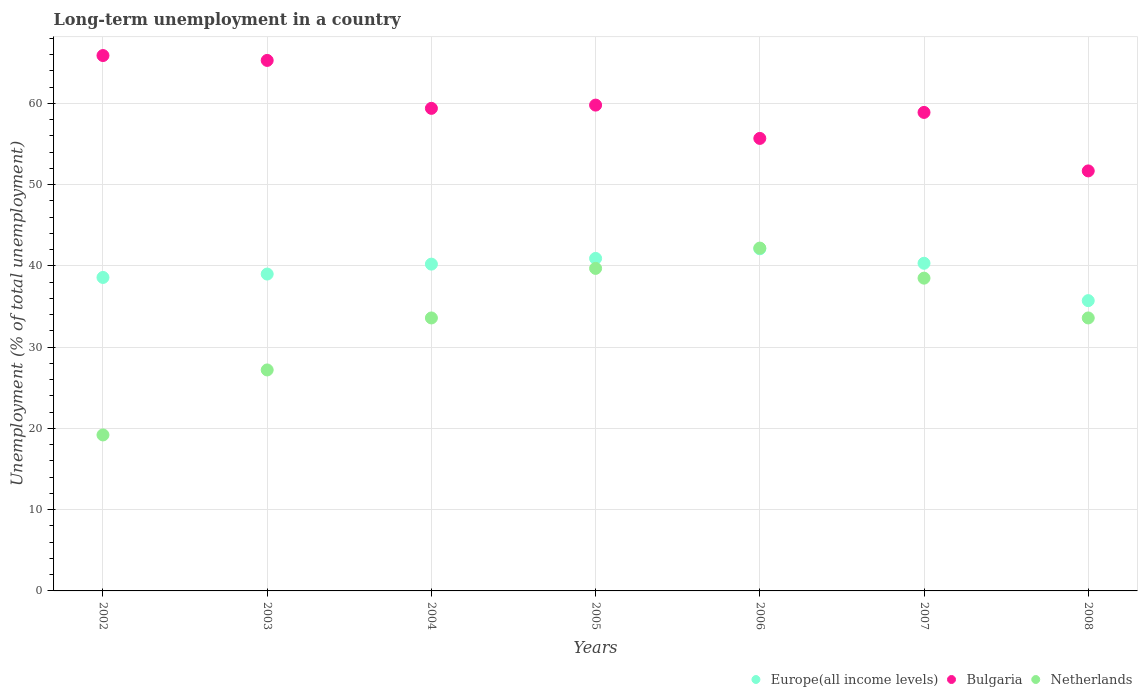Is the number of dotlines equal to the number of legend labels?
Offer a terse response. Yes. What is the percentage of long-term unemployed population in Europe(all income levels) in 2002?
Your response must be concise. 38.59. Across all years, what is the maximum percentage of long-term unemployed population in Europe(all income levels)?
Offer a very short reply. 42.11. Across all years, what is the minimum percentage of long-term unemployed population in Netherlands?
Give a very brief answer. 19.2. In which year was the percentage of long-term unemployed population in Europe(all income levels) maximum?
Make the answer very short. 2006. In which year was the percentage of long-term unemployed population in Netherlands minimum?
Provide a short and direct response. 2002. What is the total percentage of long-term unemployed population in Bulgaria in the graph?
Offer a very short reply. 416.7. What is the difference between the percentage of long-term unemployed population in Europe(all income levels) in 2004 and that in 2006?
Keep it short and to the point. -1.89. What is the difference between the percentage of long-term unemployed population in Bulgaria in 2004 and the percentage of long-term unemployed population in Netherlands in 2005?
Make the answer very short. 19.7. What is the average percentage of long-term unemployed population in Europe(all income levels) per year?
Offer a very short reply. 39.56. In the year 2003, what is the difference between the percentage of long-term unemployed population in Bulgaria and percentage of long-term unemployed population in Netherlands?
Offer a terse response. 38.1. In how many years, is the percentage of long-term unemployed population in Europe(all income levels) greater than 48 %?
Your response must be concise. 0. What is the ratio of the percentage of long-term unemployed population in Netherlands in 2005 to that in 2007?
Your response must be concise. 1.03. Is the percentage of long-term unemployed population in Bulgaria in 2002 less than that in 2008?
Provide a succinct answer. No. Is the difference between the percentage of long-term unemployed population in Bulgaria in 2003 and 2007 greater than the difference between the percentage of long-term unemployed population in Netherlands in 2003 and 2007?
Your answer should be very brief. Yes. What is the difference between the highest and the second highest percentage of long-term unemployed population in Netherlands?
Offer a very short reply. 2.5. What is the difference between the highest and the lowest percentage of long-term unemployed population in Europe(all income levels)?
Your answer should be very brief. 6.38. In how many years, is the percentage of long-term unemployed population in Netherlands greater than the average percentage of long-term unemployed population in Netherlands taken over all years?
Make the answer very short. 5. Is the sum of the percentage of long-term unemployed population in Europe(all income levels) in 2003 and 2008 greater than the maximum percentage of long-term unemployed population in Bulgaria across all years?
Your answer should be very brief. Yes. Does the percentage of long-term unemployed population in Europe(all income levels) monotonically increase over the years?
Keep it short and to the point. No. Is the percentage of long-term unemployed population in Bulgaria strictly greater than the percentage of long-term unemployed population in Europe(all income levels) over the years?
Ensure brevity in your answer.  Yes. Is the percentage of long-term unemployed population in Bulgaria strictly less than the percentage of long-term unemployed population in Netherlands over the years?
Provide a short and direct response. No. How many years are there in the graph?
Keep it short and to the point. 7. Does the graph contain grids?
Provide a succinct answer. Yes. Where does the legend appear in the graph?
Provide a short and direct response. Bottom right. How are the legend labels stacked?
Provide a succinct answer. Horizontal. What is the title of the graph?
Your answer should be very brief. Long-term unemployment in a country. Does "South Sudan" appear as one of the legend labels in the graph?
Your answer should be very brief. No. What is the label or title of the Y-axis?
Provide a succinct answer. Unemployment (% of total unemployment). What is the Unemployment (% of total unemployment) of Europe(all income levels) in 2002?
Give a very brief answer. 38.59. What is the Unemployment (% of total unemployment) of Bulgaria in 2002?
Your response must be concise. 65.9. What is the Unemployment (% of total unemployment) of Netherlands in 2002?
Give a very brief answer. 19.2. What is the Unemployment (% of total unemployment) in Europe(all income levels) in 2003?
Make the answer very short. 39. What is the Unemployment (% of total unemployment) in Bulgaria in 2003?
Give a very brief answer. 65.3. What is the Unemployment (% of total unemployment) in Netherlands in 2003?
Ensure brevity in your answer.  27.2. What is the Unemployment (% of total unemployment) of Europe(all income levels) in 2004?
Make the answer very short. 40.22. What is the Unemployment (% of total unemployment) in Bulgaria in 2004?
Make the answer very short. 59.4. What is the Unemployment (% of total unemployment) in Netherlands in 2004?
Your answer should be compact. 33.6. What is the Unemployment (% of total unemployment) in Europe(all income levels) in 2005?
Provide a short and direct response. 40.93. What is the Unemployment (% of total unemployment) of Bulgaria in 2005?
Your response must be concise. 59.8. What is the Unemployment (% of total unemployment) of Netherlands in 2005?
Give a very brief answer. 39.7. What is the Unemployment (% of total unemployment) in Europe(all income levels) in 2006?
Offer a terse response. 42.11. What is the Unemployment (% of total unemployment) of Bulgaria in 2006?
Your response must be concise. 55.7. What is the Unemployment (% of total unemployment) of Netherlands in 2006?
Your answer should be compact. 42.2. What is the Unemployment (% of total unemployment) of Europe(all income levels) in 2007?
Provide a short and direct response. 40.33. What is the Unemployment (% of total unemployment) of Bulgaria in 2007?
Ensure brevity in your answer.  58.9. What is the Unemployment (% of total unemployment) of Netherlands in 2007?
Ensure brevity in your answer.  38.5. What is the Unemployment (% of total unemployment) of Europe(all income levels) in 2008?
Give a very brief answer. 35.73. What is the Unemployment (% of total unemployment) in Bulgaria in 2008?
Make the answer very short. 51.7. What is the Unemployment (% of total unemployment) in Netherlands in 2008?
Your answer should be very brief. 33.6. Across all years, what is the maximum Unemployment (% of total unemployment) of Europe(all income levels)?
Make the answer very short. 42.11. Across all years, what is the maximum Unemployment (% of total unemployment) of Bulgaria?
Your answer should be compact. 65.9. Across all years, what is the maximum Unemployment (% of total unemployment) in Netherlands?
Offer a very short reply. 42.2. Across all years, what is the minimum Unemployment (% of total unemployment) of Europe(all income levels)?
Provide a succinct answer. 35.73. Across all years, what is the minimum Unemployment (% of total unemployment) in Bulgaria?
Your response must be concise. 51.7. Across all years, what is the minimum Unemployment (% of total unemployment) of Netherlands?
Your answer should be very brief. 19.2. What is the total Unemployment (% of total unemployment) in Europe(all income levels) in the graph?
Keep it short and to the point. 276.92. What is the total Unemployment (% of total unemployment) in Bulgaria in the graph?
Give a very brief answer. 416.7. What is the total Unemployment (% of total unemployment) of Netherlands in the graph?
Make the answer very short. 234. What is the difference between the Unemployment (% of total unemployment) in Europe(all income levels) in 2002 and that in 2003?
Keep it short and to the point. -0.42. What is the difference between the Unemployment (% of total unemployment) in Bulgaria in 2002 and that in 2003?
Ensure brevity in your answer.  0.6. What is the difference between the Unemployment (% of total unemployment) in Europe(all income levels) in 2002 and that in 2004?
Offer a terse response. -1.64. What is the difference between the Unemployment (% of total unemployment) of Netherlands in 2002 and that in 2004?
Offer a terse response. -14.4. What is the difference between the Unemployment (% of total unemployment) in Europe(all income levels) in 2002 and that in 2005?
Give a very brief answer. -2.34. What is the difference between the Unemployment (% of total unemployment) in Bulgaria in 2002 and that in 2005?
Provide a short and direct response. 6.1. What is the difference between the Unemployment (% of total unemployment) of Netherlands in 2002 and that in 2005?
Provide a short and direct response. -20.5. What is the difference between the Unemployment (% of total unemployment) of Europe(all income levels) in 2002 and that in 2006?
Make the answer very short. -3.53. What is the difference between the Unemployment (% of total unemployment) of Bulgaria in 2002 and that in 2006?
Make the answer very short. 10.2. What is the difference between the Unemployment (% of total unemployment) of Europe(all income levels) in 2002 and that in 2007?
Ensure brevity in your answer.  -1.74. What is the difference between the Unemployment (% of total unemployment) in Bulgaria in 2002 and that in 2007?
Provide a succinct answer. 7. What is the difference between the Unemployment (% of total unemployment) of Netherlands in 2002 and that in 2007?
Offer a very short reply. -19.3. What is the difference between the Unemployment (% of total unemployment) in Europe(all income levels) in 2002 and that in 2008?
Give a very brief answer. 2.85. What is the difference between the Unemployment (% of total unemployment) in Netherlands in 2002 and that in 2008?
Your answer should be compact. -14.4. What is the difference between the Unemployment (% of total unemployment) of Europe(all income levels) in 2003 and that in 2004?
Your answer should be compact. -1.22. What is the difference between the Unemployment (% of total unemployment) in Europe(all income levels) in 2003 and that in 2005?
Give a very brief answer. -1.93. What is the difference between the Unemployment (% of total unemployment) in Europe(all income levels) in 2003 and that in 2006?
Provide a succinct answer. -3.11. What is the difference between the Unemployment (% of total unemployment) in Bulgaria in 2003 and that in 2006?
Keep it short and to the point. 9.6. What is the difference between the Unemployment (% of total unemployment) in Netherlands in 2003 and that in 2006?
Your answer should be compact. -15. What is the difference between the Unemployment (% of total unemployment) in Europe(all income levels) in 2003 and that in 2007?
Offer a very short reply. -1.33. What is the difference between the Unemployment (% of total unemployment) in Europe(all income levels) in 2003 and that in 2008?
Your answer should be very brief. 3.27. What is the difference between the Unemployment (% of total unemployment) of Netherlands in 2003 and that in 2008?
Your answer should be compact. -6.4. What is the difference between the Unemployment (% of total unemployment) in Europe(all income levels) in 2004 and that in 2005?
Your response must be concise. -0.7. What is the difference between the Unemployment (% of total unemployment) of Bulgaria in 2004 and that in 2005?
Ensure brevity in your answer.  -0.4. What is the difference between the Unemployment (% of total unemployment) of Netherlands in 2004 and that in 2005?
Your answer should be very brief. -6.1. What is the difference between the Unemployment (% of total unemployment) of Europe(all income levels) in 2004 and that in 2006?
Offer a terse response. -1.89. What is the difference between the Unemployment (% of total unemployment) of Bulgaria in 2004 and that in 2006?
Offer a very short reply. 3.7. What is the difference between the Unemployment (% of total unemployment) in Europe(all income levels) in 2004 and that in 2007?
Your answer should be compact. -0.11. What is the difference between the Unemployment (% of total unemployment) of Europe(all income levels) in 2004 and that in 2008?
Your answer should be very brief. 4.49. What is the difference between the Unemployment (% of total unemployment) of Bulgaria in 2004 and that in 2008?
Provide a short and direct response. 7.7. What is the difference between the Unemployment (% of total unemployment) of Europe(all income levels) in 2005 and that in 2006?
Your response must be concise. -1.19. What is the difference between the Unemployment (% of total unemployment) in Bulgaria in 2005 and that in 2006?
Your answer should be very brief. 4.1. What is the difference between the Unemployment (% of total unemployment) in Netherlands in 2005 and that in 2006?
Ensure brevity in your answer.  -2.5. What is the difference between the Unemployment (% of total unemployment) of Europe(all income levels) in 2005 and that in 2007?
Your answer should be very brief. 0.6. What is the difference between the Unemployment (% of total unemployment) of Bulgaria in 2005 and that in 2007?
Offer a very short reply. 0.9. What is the difference between the Unemployment (% of total unemployment) in Netherlands in 2005 and that in 2007?
Offer a very short reply. 1.2. What is the difference between the Unemployment (% of total unemployment) of Europe(all income levels) in 2005 and that in 2008?
Provide a short and direct response. 5.2. What is the difference between the Unemployment (% of total unemployment) in Europe(all income levels) in 2006 and that in 2007?
Offer a terse response. 1.78. What is the difference between the Unemployment (% of total unemployment) of Bulgaria in 2006 and that in 2007?
Ensure brevity in your answer.  -3.2. What is the difference between the Unemployment (% of total unemployment) in Netherlands in 2006 and that in 2007?
Offer a very short reply. 3.7. What is the difference between the Unemployment (% of total unemployment) of Europe(all income levels) in 2006 and that in 2008?
Your answer should be very brief. 6.38. What is the difference between the Unemployment (% of total unemployment) of Bulgaria in 2006 and that in 2008?
Provide a succinct answer. 4. What is the difference between the Unemployment (% of total unemployment) of Europe(all income levels) in 2007 and that in 2008?
Provide a succinct answer. 4.6. What is the difference between the Unemployment (% of total unemployment) of Europe(all income levels) in 2002 and the Unemployment (% of total unemployment) of Bulgaria in 2003?
Your answer should be very brief. -26.71. What is the difference between the Unemployment (% of total unemployment) in Europe(all income levels) in 2002 and the Unemployment (% of total unemployment) in Netherlands in 2003?
Your answer should be very brief. 11.39. What is the difference between the Unemployment (% of total unemployment) in Bulgaria in 2002 and the Unemployment (% of total unemployment) in Netherlands in 2003?
Your answer should be compact. 38.7. What is the difference between the Unemployment (% of total unemployment) of Europe(all income levels) in 2002 and the Unemployment (% of total unemployment) of Bulgaria in 2004?
Provide a short and direct response. -20.81. What is the difference between the Unemployment (% of total unemployment) in Europe(all income levels) in 2002 and the Unemployment (% of total unemployment) in Netherlands in 2004?
Make the answer very short. 4.99. What is the difference between the Unemployment (% of total unemployment) in Bulgaria in 2002 and the Unemployment (% of total unemployment) in Netherlands in 2004?
Make the answer very short. 32.3. What is the difference between the Unemployment (% of total unemployment) of Europe(all income levels) in 2002 and the Unemployment (% of total unemployment) of Bulgaria in 2005?
Give a very brief answer. -21.21. What is the difference between the Unemployment (% of total unemployment) in Europe(all income levels) in 2002 and the Unemployment (% of total unemployment) in Netherlands in 2005?
Give a very brief answer. -1.11. What is the difference between the Unemployment (% of total unemployment) in Bulgaria in 2002 and the Unemployment (% of total unemployment) in Netherlands in 2005?
Keep it short and to the point. 26.2. What is the difference between the Unemployment (% of total unemployment) in Europe(all income levels) in 2002 and the Unemployment (% of total unemployment) in Bulgaria in 2006?
Your response must be concise. -17.11. What is the difference between the Unemployment (% of total unemployment) of Europe(all income levels) in 2002 and the Unemployment (% of total unemployment) of Netherlands in 2006?
Your answer should be compact. -3.61. What is the difference between the Unemployment (% of total unemployment) in Bulgaria in 2002 and the Unemployment (% of total unemployment) in Netherlands in 2006?
Provide a short and direct response. 23.7. What is the difference between the Unemployment (% of total unemployment) in Europe(all income levels) in 2002 and the Unemployment (% of total unemployment) in Bulgaria in 2007?
Your answer should be very brief. -20.31. What is the difference between the Unemployment (% of total unemployment) in Europe(all income levels) in 2002 and the Unemployment (% of total unemployment) in Netherlands in 2007?
Ensure brevity in your answer.  0.09. What is the difference between the Unemployment (% of total unemployment) of Bulgaria in 2002 and the Unemployment (% of total unemployment) of Netherlands in 2007?
Provide a succinct answer. 27.4. What is the difference between the Unemployment (% of total unemployment) in Europe(all income levels) in 2002 and the Unemployment (% of total unemployment) in Bulgaria in 2008?
Give a very brief answer. -13.11. What is the difference between the Unemployment (% of total unemployment) of Europe(all income levels) in 2002 and the Unemployment (% of total unemployment) of Netherlands in 2008?
Give a very brief answer. 4.99. What is the difference between the Unemployment (% of total unemployment) in Bulgaria in 2002 and the Unemployment (% of total unemployment) in Netherlands in 2008?
Offer a terse response. 32.3. What is the difference between the Unemployment (% of total unemployment) of Europe(all income levels) in 2003 and the Unemployment (% of total unemployment) of Bulgaria in 2004?
Provide a succinct answer. -20.4. What is the difference between the Unemployment (% of total unemployment) in Europe(all income levels) in 2003 and the Unemployment (% of total unemployment) in Netherlands in 2004?
Offer a very short reply. 5.4. What is the difference between the Unemployment (% of total unemployment) in Bulgaria in 2003 and the Unemployment (% of total unemployment) in Netherlands in 2004?
Give a very brief answer. 31.7. What is the difference between the Unemployment (% of total unemployment) in Europe(all income levels) in 2003 and the Unemployment (% of total unemployment) in Bulgaria in 2005?
Offer a very short reply. -20.8. What is the difference between the Unemployment (% of total unemployment) of Europe(all income levels) in 2003 and the Unemployment (% of total unemployment) of Netherlands in 2005?
Provide a succinct answer. -0.7. What is the difference between the Unemployment (% of total unemployment) of Bulgaria in 2003 and the Unemployment (% of total unemployment) of Netherlands in 2005?
Give a very brief answer. 25.6. What is the difference between the Unemployment (% of total unemployment) in Europe(all income levels) in 2003 and the Unemployment (% of total unemployment) in Bulgaria in 2006?
Keep it short and to the point. -16.7. What is the difference between the Unemployment (% of total unemployment) of Europe(all income levels) in 2003 and the Unemployment (% of total unemployment) of Netherlands in 2006?
Provide a succinct answer. -3.2. What is the difference between the Unemployment (% of total unemployment) of Bulgaria in 2003 and the Unemployment (% of total unemployment) of Netherlands in 2006?
Make the answer very short. 23.1. What is the difference between the Unemployment (% of total unemployment) in Europe(all income levels) in 2003 and the Unemployment (% of total unemployment) in Bulgaria in 2007?
Make the answer very short. -19.9. What is the difference between the Unemployment (% of total unemployment) in Europe(all income levels) in 2003 and the Unemployment (% of total unemployment) in Netherlands in 2007?
Offer a terse response. 0.5. What is the difference between the Unemployment (% of total unemployment) of Bulgaria in 2003 and the Unemployment (% of total unemployment) of Netherlands in 2007?
Offer a very short reply. 26.8. What is the difference between the Unemployment (% of total unemployment) in Europe(all income levels) in 2003 and the Unemployment (% of total unemployment) in Bulgaria in 2008?
Your response must be concise. -12.7. What is the difference between the Unemployment (% of total unemployment) in Europe(all income levels) in 2003 and the Unemployment (% of total unemployment) in Netherlands in 2008?
Your response must be concise. 5.4. What is the difference between the Unemployment (% of total unemployment) in Bulgaria in 2003 and the Unemployment (% of total unemployment) in Netherlands in 2008?
Make the answer very short. 31.7. What is the difference between the Unemployment (% of total unemployment) of Europe(all income levels) in 2004 and the Unemployment (% of total unemployment) of Bulgaria in 2005?
Your response must be concise. -19.58. What is the difference between the Unemployment (% of total unemployment) in Europe(all income levels) in 2004 and the Unemployment (% of total unemployment) in Netherlands in 2005?
Offer a very short reply. 0.52. What is the difference between the Unemployment (% of total unemployment) in Europe(all income levels) in 2004 and the Unemployment (% of total unemployment) in Bulgaria in 2006?
Provide a short and direct response. -15.48. What is the difference between the Unemployment (% of total unemployment) of Europe(all income levels) in 2004 and the Unemployment (% of total unemployment) of Netherlands in 2006?
Your answer should be compact. -1.98. What is the difference between the Unemployment (% of total unemployment) of Europe(all income levels) in 2004 and the Unemployment (% of total unemployment) of Bulgaria in 2007?
Make the answer very short. -18.68. What is the difference between the Unemployment (% of total unemployment) in Europe(all income levels) in 2004 and the Unemployment (% of total unemployment) in Netherlands in 2007?
Offer a very short reply. 1.72. What is the difference between the Unemployment (% of total unemployment) in Bulgaria in 2004 and the Unemployment (% of total unemployment) in Netherlands in 2007?
Make the answer very short. 20.9. What is the difference between the Unemployment (% of total unemployment) in Europe(all income levels) in 2004 and the Unemployment (% of total unemployment) in Bulgaria in 2008?
Your answer should be compact. -11.48. What is the difference between the Unemployment (% of total unemployment) in Europe(all income levels) in 2004 and the Unemployment (% of total unemployment) in Netherlands in 2008?
Your answer should be very brief. 6.62. What is the difference between the Unemployment (% of total unemployment) in Bulgaria in 2004 and the Unemployment (% of total unemployment) in Netherlands in 2008?
Give a very brief answer. 25.8. What is the difference between the Unemployment (% of total unemployment) of Europe(all income levels) in 2005 and the Unemployment (% of total unemployment) of Bulgaria in 2006?
Your response must be concise. -14.77. What is the difference between the Unemployment (% of total unemployment) of Europe(all income levels) in 2005 and the Unemployment (% of total unemployment) of Netherlands in 2006?
Make the answer very short. -1.27. What is the difference between the Unemployment (% of total unemployment) of Bulgaria in 2005 and the Unemployment (% of total unemployment) of Netherlands in 2006?
Your response must be concise. 17.6. What is the difference between the Unemployment (% of total unemployment) in Europe(all income levels) in 2005 and the Unemployment (% of total unemployment) in Bulgaria in 2007?
Your answer should be compact. -17.97. What is the difference between the Unemployment (% of total unemployment) of Europe(all income levels) in 2005 and the Unemployment (% of total unemployment) of Netherlands in 2007?
Your answer should be compact. 2.43. What is the difference between the Unemployment (% of total unemployment) in Bulgaria in 2005 and the Unemployment (% of total unemployment) in Netherlands in 2007?
Provide a succinct answer. 21.3. What is the difference between the Unemployment (% of total unemployment) in Europe(all income levels) in 2005 and the Unemployment (% of total unemployment) in Bulgaria in 2008?
Give a very brief answer. -10.77. What is the difference between the Unemployment (% of total unemployment) in Europe(all income levels) in 2005 and the Unemployment (% of total unemployment) in Netherlands in 2008?
Ensure brevity in your answer.  7.33. What is the difference between the Unemployment (% of total unemployment) of Bulgaria in 2005 and the Unemployment (% of total unemployment) of Netherlands in 2008?
Make the answer very short. 26.2. What is the difference between the Unemployment (% of total unemployment) of Europe(all income levels) in 2006 and the Unemployment (% of total unemployment) of Bulgaria in 2007?
Give a very brief answer. -16.79. What is the difference between the Unemployment (% of total unemployment) of Europe(all income levels) in 2006 and the Unemployment (% of total unemployment) of Netherlands in 2007?
Your response must be concise. 3.61. What is the difference between the Unemployment (% of total unemployment) of Bulgaria in 2006 and the Unemployment (% of total unemployment) of Netherlands in 2007?
Provide a short and direct response. 17.2. What is the difference between the Unemployment (% of total unemployment) of Europe(all income levels) in 2006 and the Unemployment (% of total unemployment) of Bulgaria in 2008?
Offer a terse response. -9.59. What is the difference between the Unemployment (% of total unemployment) in Europe(all income levels) in 2006 and the Unemployment (% of total unemployment) in Netherlands in 2008?
Offer a terse response. 8.51. What is the difference between the Unemployment (% of total unemployment) in Bulgaria in 2006 and the Unemployment (% of total unemployment) in Netherlands in 2008?
Ensure brevity in your answer.  22.1. What is the difference between the Unemployment (% of total unemployment) in Europe(all income levels) in 2007 and the Unemployment (% of total unemployment) in Bulgaria in 2008?
Provide a short and direct response. -11.37. What is the difference between the Unemployment (% of total unemployment) in Europe(all income levels) in 2007 and the Unemployment (% of total unemployment) in Netherlands in 2008?
Provide a succinct answer. 6.73. What is the difference between the Unemployment (% of total unemployment) in Bulgaria in 2007 and the Unemployment (% of total unemployment) in Netherlands in 2008?
Your answer should be compact. 25.3. What is the average Unemployment (% of total unemployment) of Europe(all income levels) per year?
Ensure brevity in your answer.  39.56. What is the average Unemployment (% of total unemployment) of Bulgaria per year?
Offer a terse response. 59.53. What is the average Unemployment (% of total unemployment) of Netherlands per year?
Ensure brevity in your answer.  33.43. In the year 2002, what is the difference between the Unemployment (% of total unemployment) of Europe(all income levels) and Unemployment (% of total unemployment) of Bulgaria?
Make the answer very short. -27.31. In the year 2002, what is the difference between the Unemployment (% of total unemployment) in Europe(all income levels) and Unemployment (% of total unemployment) in Netherlands?
Give a very brief answer. 19.39. In the year 2002, what is the difference between the Unemployment (% of total unemployment) of Bulgaria and Unemployment (% of total unemployment) of Netherlands?
Make the answer very short. 46.7. In the year 2003, what is the difference between the Unemployment (% of total unemployment) in Europe(all income levels) and Unemployment (% of total unemployment) in Bulgaria?
Your answer should be compact. -26.3. In the year 2003, what is the difference between the Unemployment (% of total unemployment) in Europe(all income levels) and Unemployment (% of total unemployment) in Netherlands?
Offer a very short reply. 11.8. In the year 2003, what is the difference between the Unemployment (% of total unemployment) of Bulgaria and Unemployment (% of total unemployment) of Netherlands?
Provide a short and direct response. 38.1. In the year 2004, what is the difference between the Unemployment (% of total unemployment) in Europe(all income levels) and Unemployment (% of total unemployment) in Bulgaria?
Keep it short and to the point. -19.18. In the year 2004, what is the difference between the Unemployment (% of total unemployment) in Europe(all income levels) and Unemployment (% of total unemployment) in Netherlands?
Give a very brief answer. 6.62. In the year 2004, what is the difference between the Unemployment (% of total unemployment) of Bulgaria and Unemployment (% of total unemployment) of Netherlands?
Give a very brief answer. 25.8. In the year 2005, what is the difference between the Unemployment (% of total unemployment) of Europe(all income levels) and Unemployment (% of total unemployment) of Bulgaria?
Provide a short and direct response. -18.87. In the year 2005, what is the difference between the Unemployment (% of total unemployment) of Europe(all income levels) and Unemployment (% of total unemployment) of Netherlands?
Offer a very short reply. 1.23. In the year 2005, what is the difference between the Unemployment (% of total unemployment) of Bulgaria and Unemployment (% of total unemployment) of Netherlands?
Your answer should be compact. 20.1. In the year 2006, what is the difference between the Unemployment (% of total unemployment) in Europe(all income levels) and Unemployment (% of total unemployment) in Bulgaria?
Provide a succinct answer. -13.59. In the year 2006, what is the difference between the Unemployment (% of total unemployment) of Europe(all income levels) and Unemployment (% of total unemployment) of Netherlands?
Provide a succinct answer. -0.09. In the year 2006, what is the difference between the Unemployment (% of total unemployment) of Bulgaria and Unemployment (% of total unemployment) of Netherlands?
Ensure brevity in your answer.  13.5. In the year 2007, what is the difference between the Unemployment (% of total unemployment) in Europe(all income levels) and Unemployment (% of total unemployment) in Bulgaria?
Give a very brief answer. -18.57. In the year 2007, what is the difference between the Unemployment (% of total unemployment) of Europe(all income levels) and Unemployment (% of total unemployment) of Netherlands?
Your answer should be very brief. 1.83. In the year 2007, what is the difference between the Unemployment (% of total unemployment) in Bulgaria and Unemployment (% of total unemployment) in Netherlands?
Provide a succinct answer. 20.4. In the year 2008, what is the difference between the Unemployment (% of total unemployment) in Europe(all income levels) and Unemployment (% of total unemployment) in Bulgaria?
Your response must be concise. -15.97. In the year 2008, what is the difference between the Unemployment (% of total unemployment) in Europe(all income levels) and Unemployment (% of total unemployment) in Netherlands?
Keep it short and to the point. 2.13. What is the ratio of the Unemployment (% of total unemployment) in Europe(all income levels) in 2002 to that in 2003?
Give a very brief answer. 0.99. What is the ratio of the Unemployment (% of total unemployment) in Bulgaria in 2002 to that in 2003?
Give a very brief answer. 1.01. What is the ratio of the Unemployment (% of total unemployment) of Netherlands in 2002 to that in 2003?
Give a very brief answer. 0.71. What is the ratio of the Unemployment (% of total unemployment) in Europe(all income levels) in 2002 to that in 2004?
Provide a short and direct response. 0.96. What is the ratio of the Unemployment (% of total unemployment) in Bulgaria in 2002 to that in 2004?
Your answer should be compact. 1.11. What is the ratio of the Unemployment (% of total unemployment) in Europe(all income levels) in 2002 to that in 2005?
Offer a terse response. 0.94. What is the ratio of the Unemployment (% of total unemployment) of Bulgaria in 2002 to that in 2005?
Your answer should be very brief. 1.1. What is the ratio of the Unemployment (% of total unemployment) of Netherlands in 2002 to that in 2005?
Provide a succinct answer. 0.48. What is the ratio of the Unemployment (% of total unemployment) of Europe(all income levels) in 2002 to that in 2006?
Offer a terse response. 0.92. What is the ratio of the Unemployment (% of total unemployment) of Bulgaria in 2002 to that in 2006?
Offer a terse response. 1.18. What is the ratio of the Unemployment (% of total unemployment) in Netherlands in 2002 to that in 2006?
Your answer should be compact. 0.46. What is the ratio of the Unemployment (% of total unemployment) in Europe(all income levels) in 2002 to that in 2007?
Provide a short and direct response. 0.96. What is the ratio of the Unemployment (% of total unemployment) of Bulgaria in 2002 to that in 2007?
Offer a very short reply. 1.12. What is the ratio of the Unemployment (% of total unemployment) in Netherlands in 2002 to that in 2007?
Your response must be concise. 0.5. What is the ratio of the Unemployment (% of total unemployment) of Europe(all income levels) in 2002 to that in 2008?
Keep it short and to the point. 1.08. What is the ratio of the Unemployment (% of total unemployment) of Bulgaria in 2002 to that in 2008?
Your answer should be very brief. 1.27. What is the ratio of the Unemployment (% of total unemployment) in Europe(all income levels) in 2003 to that in 2004?
Ensure brevity in your answer.  0.97. What is the ratio of the Unemployment (% of total unemployment) of Bulgaria in 2003 to that in 2004?
Offer a terse response. 1.1. What is the ratio of the Unemployment (% of total unemployment) of Netherlands in 2003 to that in 2004?
Provide a short and direct response. 0.81. What is the ratio of the Unemployment (% of total unemployment) in Europe(all income levels) in 2003 to that in 2005?
Give a very brief answer. 0.95. What is the ratio of the Unemployment (% of total unemployment) in Bulgaria in 2003 to that in 2005?
Give a very brief answer. 1.09. What is the ratio of the Unemployment (% of total unemployment) of Netherlands in 2003 to that in 2005?
Your response must be concise. 0.69. What is the ratio of the Unemployment (% of total unemployment) of Europe(all income levels) in 2003 to that in 2006?
Provide a succinct answer. 0.93. What is the ratio of the Unemployment (% of total unemployment) in Bulgaria in 2003 to that in 2006?
Give a very brief answer. 1.17. What is the ratio of the Unemployment (% of total unemployment) of Netherlands in 2003 to that in 2006?
Provide a succinct answer. 0.64. What is the ratio of the Unemployment (% of total unemployment) of Europe(all income levels) in 2003 to that in 2007?
Make the answer very short. 0.97. What is the ratio of the Unemployment (% of total unemployment) of Bulgaria in 2003 to that in 2007?
Your answer should be very brief. 1.11. What is the ratio of the Unemployment (% of total unemployment) of Netherlands in 2003 to that in 2007?
Keep it short and to the point. 0.71. What is the ratio of the Unemployment (% of total unemployment) in Europe(all income levels) in 2003 to that in 2008?
Provide a short and direct response. 1.09. What is the ratio of the Unemployment (% of total unemployment) of Bulgaria in 2003 to that in 2008?
Your answer should be very brief. 1.26. What is the ratio of the Unemployment (% of total unemployment) of Netherlands in 2003 to that in 2008?
Keep it short and to the point. 0.81. What is the ratio of the Unemployment (% of total unemployment) in Europe(all income levels) in 2004 to that in 2005?
Offer a very short reply. 0.98. What is the ratio of the Unemployment (% of total unemployment) of Netherlands in 2004 to that in 2005?
Give a very brief answer. 0.85. What is the ratio of the Unemployment (% of total unemployment) of Europe(all income levels) in 2004 to that in 2006?
Your answer should be very brief. 0.96. What is the ratio of the Unemployment (% of total unemployment) of Bulgaria in 2004 to that in 2006?
Provide a succinct answer. 1.07. What is the ratio of the Unemployment (% of total unemployment) of Netherlands in 2004 to that in 2006?
Make the answer very short. 0.8. What is the ratio of the Unemployment (% of total unemployment) in Europe(all income levels) in 2004 to that in 2007?
Offer a very short reply. 1. What is the ratio of the Unemployment (% of total unemployment) in Bulgaria in 2004 to that in 2007?
Give a very brief answer. 1.01. What is the ratio of the Unemployment (% of total unemployment) in Netherlands in 2004 to that in 2007?
Ensure brevity in your answer.  0.87. What is the ratio of the Unemployment (% of total unemployment) in Europe(all income levels) in 2004 to that in 2008?
Your answer should be very brief. 1.13. What is the ratio of the Unemployment (% of total unemployment) in Bulgaria in 2004 to that in 2008?
Give a very brief answer. 1.15. What is the ratio of the Unemployment (% of total unemployment) of Netherlands in 2004 to that in 2008?
Keep it short and to the point. 1. What is the ratio of the Unemployment (% of total unemployment) of Europe(all income levels) in 2005 to that in 2006?
Provide a succinct answer. 0.97. What is the ratio of the Unemployment (% of total unemployment) of Bulgaria in 2005 to that in 2006?
Your answer should be compact. 1.07. What is the ratio of the Unemployment (% of total unemployment) of Netherlands in 2005 to that in 2006?
Make the answer very short. 0.94. What is the ratio of the Unemployment (% of total unemployment) in Europe(all income levels) in 2005 to that in 2007?
Ensure brevity in your answer.  1.01. What is the ratio of the Unemployment (% of total unemployment) of Bulgaria in 2005 to that in 2007?
Your answer should be compact. 1.02. What is the ratio of the Unemployment (% of total unemployment) of Netherlands in 2005 to that in 2007?
Offer a terse response. 1.03. What is the ratio of the Unemployment (% of total unemployment) of Europe(all income levels) in 2005 to that in 2008?
Provide a short and direct response. 1.15. What is the ratio of the Unemployment (% of total unemployment) of Bulgaria in 2005 to that in 2008?
Ensure brevity in your answer.  1.16. What is the ratio of the Unemployment (% of total unemployment) of Netherlands in 2005 to that in 2008?
Provide a succinct answer. 1.18. What is the ratio of the Unemployment (% of total unemployment) of Europe(all income levels) in 2006 to that in 2007?
Offer a terse response. 1.04. What is the ratio of the Unemployment (% of total unemployment) of Bulgaria in 2006 to that in 2007?
Offer a very short reply. 0.95. What is the ratio of the Unemployment (% of total unemployment) in Netherlands in 2006 to that in 2007?
Offer a very short reply. 1.1. What is the ratio of the Unemployment (% of total unemployment) of Europe(all income levels) in 2006 to that in 2008?
Keep it short and to the point. 1.18. What is the ratio of the Unemployment (% of total unemployment) in Bulgaria in 2006 to that in 2008?
Provide a short and direct response. 1.08. What is the ratio of the Unemployment (% of total unemployment) of Netherlands in 2006 to that in 2008?
Offer a very short reply. 1.26. What is the ratio of the Unemployment (% of total unemployment) of Europe(all income levels) in 2007 to that in 2008?
Ensure brevity in your answer.  1.13. What is the ratio of the Unemployment (% of total unemployment) of Bulgaria in 2007 to that in 2008?
Give a very brief answer. 1.14. What is the ratio of the Unemployment (% of total unemployment) of Netherlands in 2007 to that in 2008?
Offer a terse response. 1.15. What is the difference between the highest and the second highest Unemployment (% of total unemployment) of Europe(all income levels)?
Your answer should be compact. 1.19. What is the difference between the highest and the second highest Unemployment (% of total unemployment) of Netherlands?
Ensure brevity in your answer.  2.5. What is the difference between the highest and the lowest Unemployment (% of total unemployment) in Europe(all income levels)?
Your answer should be very brief. 6.38. What is the difference between the highest and the lowest Unemployment (% of total unemployment) of Bulgaria?
Provide a short and direct response. 14.2. What is the difference between the highest and the lowest Unemployment (% of total unemployment) of Netherlands?
Provide a succinct answer. 23. 